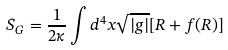Convert formula to latex. <formula><loc_0><loc_0><loc_500><loc_500>S _ { G } = \frac { 1 } { 2 \kappa } \int d ^ { 4 } x \sqrt { | g | } [ R + f ( R ) ]</formula> 